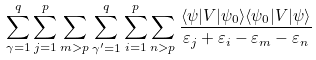<formula> <loc_0><loc_0><loc_500><loc_500>\sum _ { \gamma = 1 } ^ { q } \sum _ { j = 1 } ^ { p } \sum _ { m > p } \sum _ { \gamma ^ { \prime } = 1 } ^ { q } \sum _ { i = 1 } ^ { p } \sum _ { n > p } \frac { \langle \psi | V | \psi _ { 0 } \rangle \langle \psi _ { 0 } | V | \psi \rangle } { \varepsilon _ { j } + \varepsilon _ { i } - \varepsilon _ { m } - \varepsilon _ { n } }</formula> 